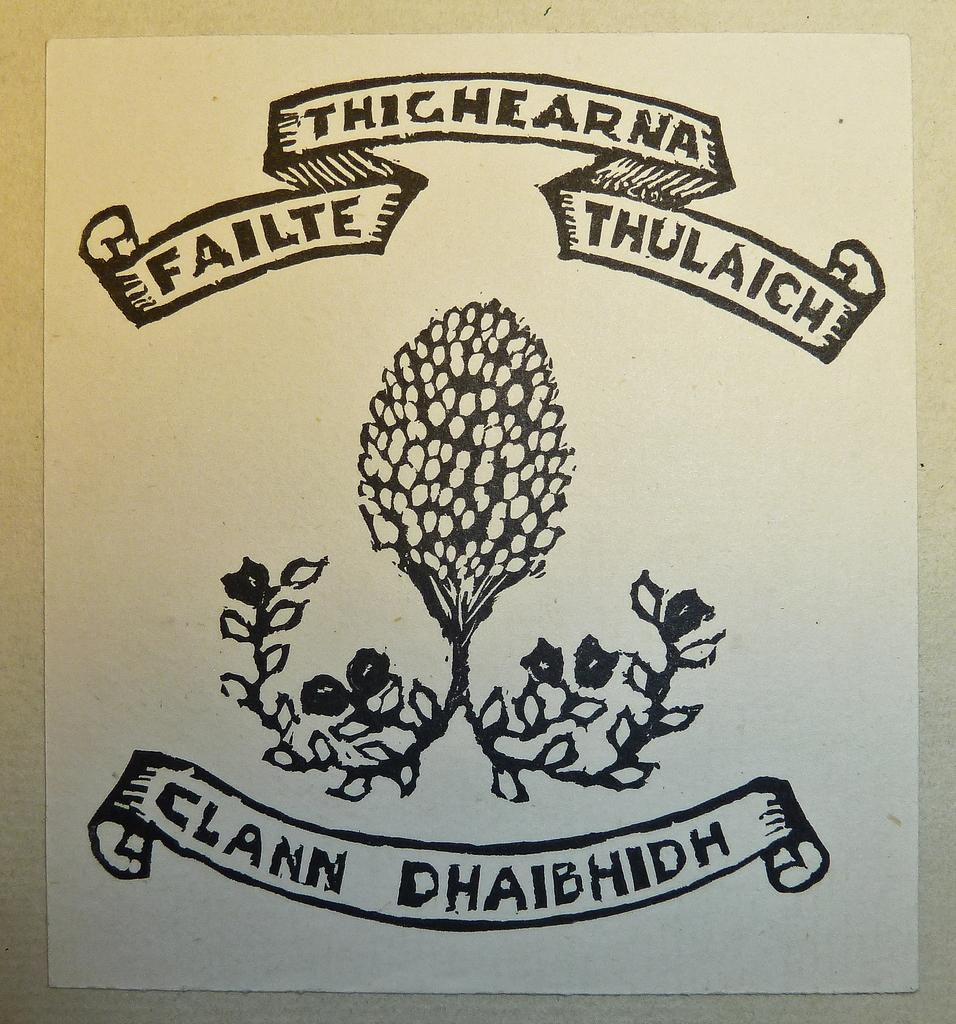What is present in the image that contains visual information? There is a poster in the image that contains images. What else can be found on the poster besides images? The poster contains text as well. What color is the sky in the image? There is no sky visible in the image; it only contains a poster with images and text. 